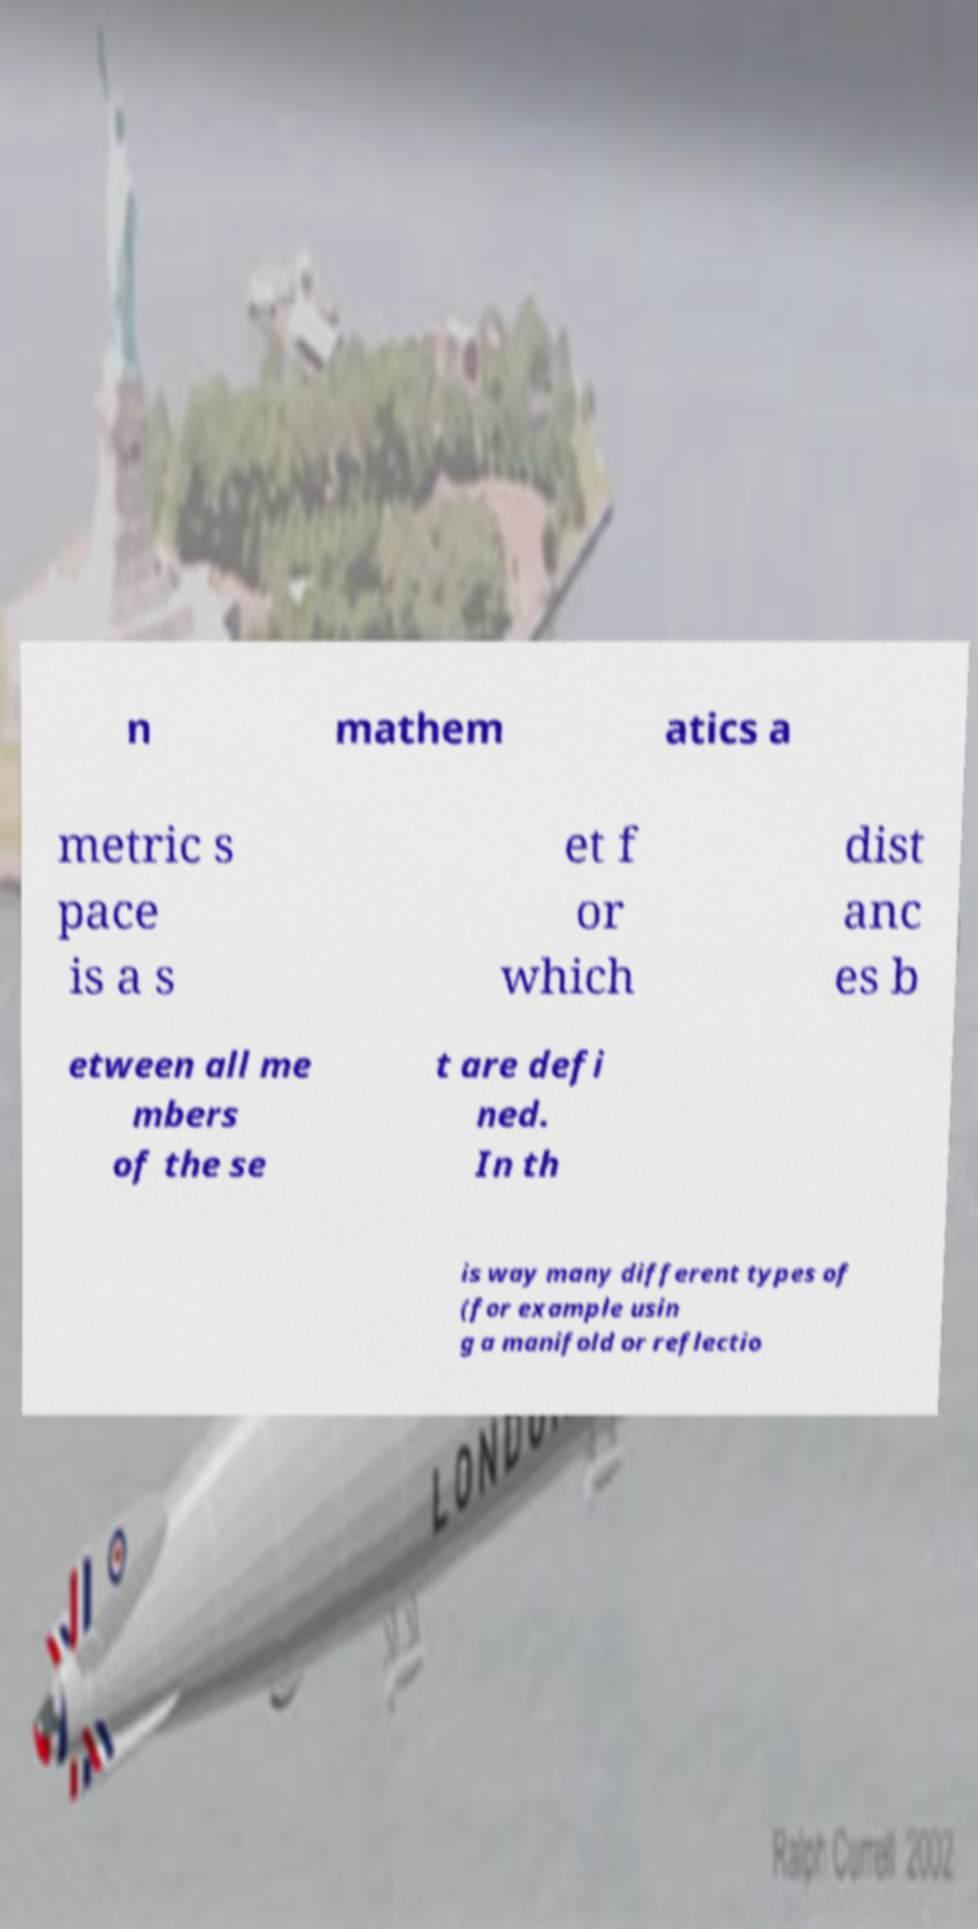Please read and relay the text visible in this image. What does it say? n mathem atics a metric s pace is a s et f or which dist anc es b etween all me mbers of the se t are defi ned. In th is way many different types of (for example usin g a manifold or reflectio 